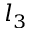<formula> <loc_0><loc_0><loc_500><loc_500>l _ { 3 }</formula> 